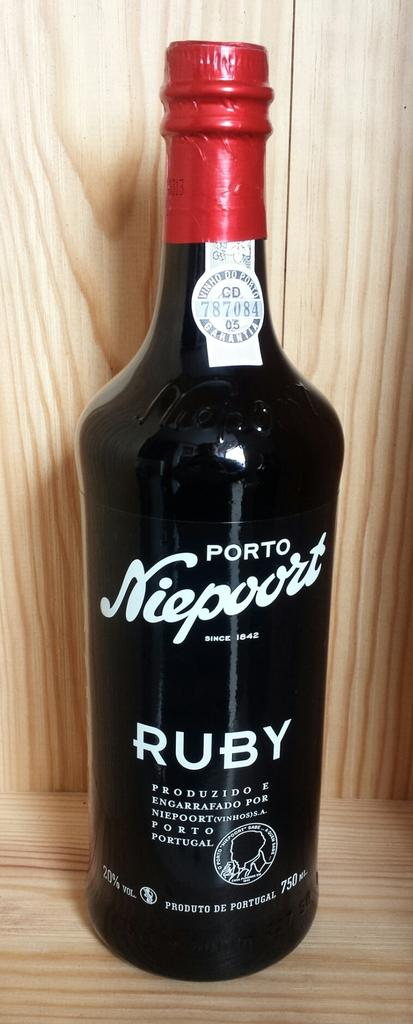<image>
Describe the image concisely. a bottle with Ruby written on it in white 